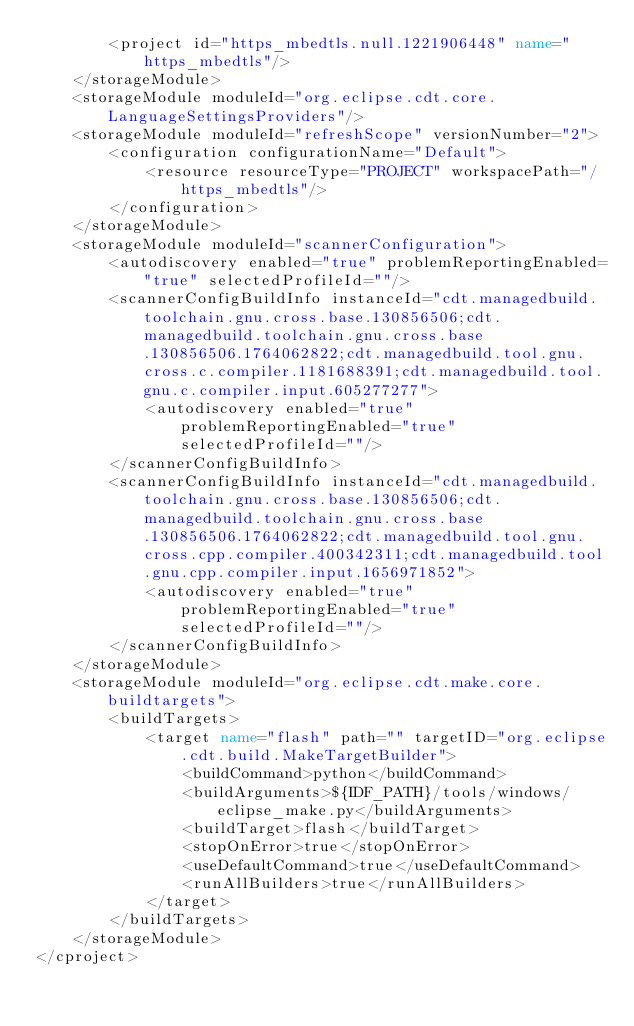<code> <loc_0><loc_0><loc_500><loc_500><_XML_>		<project id="https_mbedtls.null.1221906448" name="https_mbedtls"/>
	</storageModule>
	<storageModule moduleId="org.eclipse.cdt.core.LanguageSettingsProviders"/>
	<storageModule moduleId="refreshScope" versionNumber="2">
		<configuration configurationName="Default">
			<resource resourceType="PROJECT" workspacePath="/https_mbedtls"/>
		</configuration>
	</storageModule>
	<storageModule moduleId="scannerConfiguration">
		<autodiscovery enabled="true" problemReportingEnabled="true" selectedProfileId=""/>
		<scannerConfigBuildInfo instanceId="cdt.managedbuild.toolchain.gnu.cross.base.130856506;cdt.managedbuild.toolchain.gnu.cross.base.130856506.1764062822;cdt.managedbuild.tool.gnu.cross.c.compiler.1181688391;cdt.managedbuild.tool.gnu.c.compiler.input.605277277">
			<autodiscovery enabled="true" problemReportingEnabled="true" selectedProfileId=""/>
		</scannerConfigBuildInfo>
		<scannerConfigBuildInfo instanceId="cdt.managedbuild.toolchain.gnu.cross.base.130856506;cdt.managedbuild.toolchain.gnu.cross.base.130856506.1764062822;cdt.managedbuild.tool.gnu.cross.cpp.compiler.400342311;cdt.managedbuild.tool.gnu.cpp.compiler.input.1656971852">
			<autodiscovery enabled="true" problemReportingEnabled="true" selectedProfileId=""/>
		</scannerConfigBuildInfo>
	</storageModule>
	<storageModule moduleId="org.eclipse.cdt.make.core.buildtargets">
		<buildTargets>
			<target name="flash" path="" targetID="org.eclipse.cdt.build.MakeTargetBuilder">
				<buildCommand>python</buildCommand>
				<buildArguments>${IDF_PATH}/tools/windows/eclipse_make.py</buildArguments>
				<buildTarget>flash</buildTarget>
				<stopOnError>true</stopOnError>
				<useDefaultCommand>true</useDefaultCommand>
				<runAllBuilders>true</runAllBuilders>
			</target>
		</buildTargets>
	</storageModule>
</cproject>
</code> 